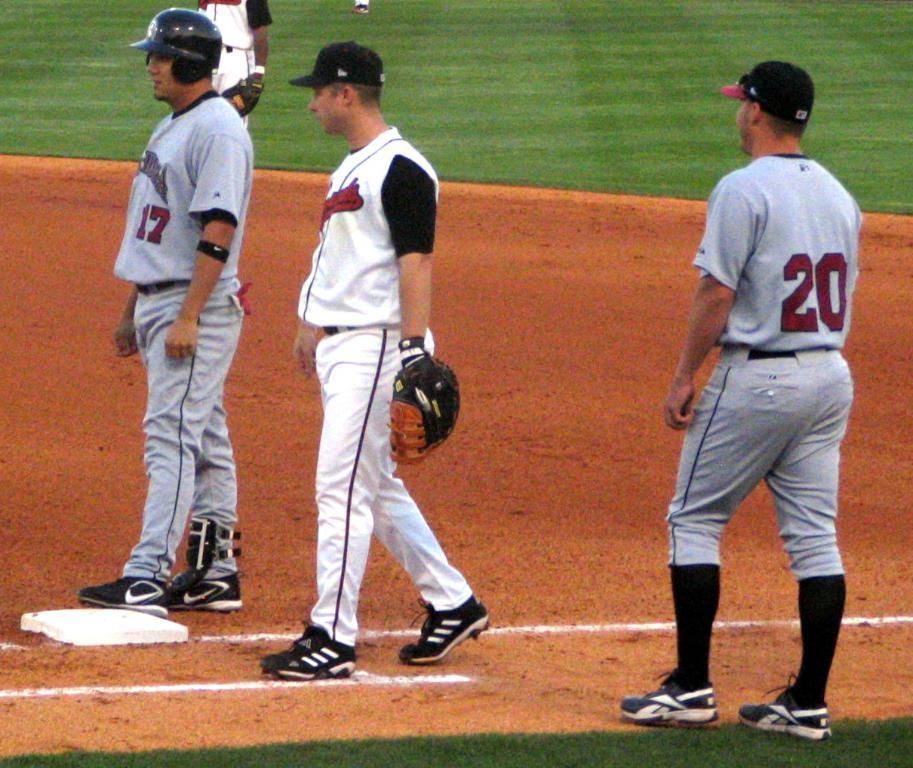<image>
Share a concise interpretation of the image provided. Three baseball players, one wearing 17 another 20, wait for the game to resume. 